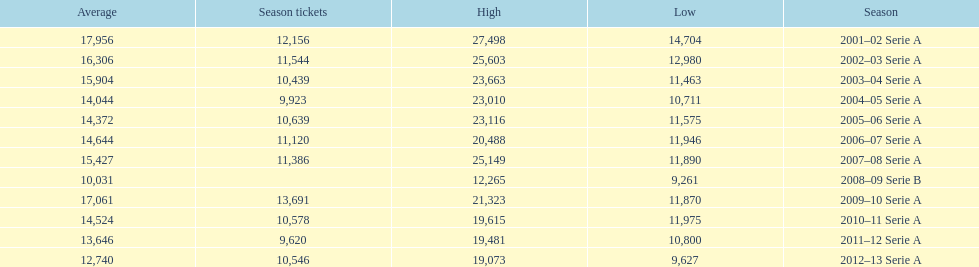Can you give me this table as a dict? {'header': ['Average', 'Season tickets', 'High', 'Low', 'Season'], 'rows': [['17,956', '12,156', '27,498', '14,704', '2001–02 Serie A'], ['16,306', '11,544', '25,603', '12,980', '2002–03 Serie A'], ['15,904', '10,439', '23,663', '11,463', '2003–04 Serie A'], ['14,044', '9,923', '23,010', '10,711', '2004–05 Serie A'], ['14,372', '10,639', '23,116', '11,575', '2005–06 Serie A'], ['14,644', '11,120', '20,488', '11,946', '2006–07 Serie A'], ['15,427', '11,386', '25,149', '11,890', '2007–08 Serie A'], ['10,031', '', '12,265', '9,261', '2008–09 Serie B'], ['17,061', '13,691', '21,323', '11,870', '2009–10 Serie A'], ['14,524', '10,578', '19,615', '11,975', '2010–11 Serie A'], ['13,646', '9,620', '19,481', '10,800', '2011–12 Serie A'], ['12,740', '10,546', '19,073', '9,627', '2012–13 Serie A']]} How many seasons had average attendance of at least 15,000 at the stadio ennio tardini? 5. 